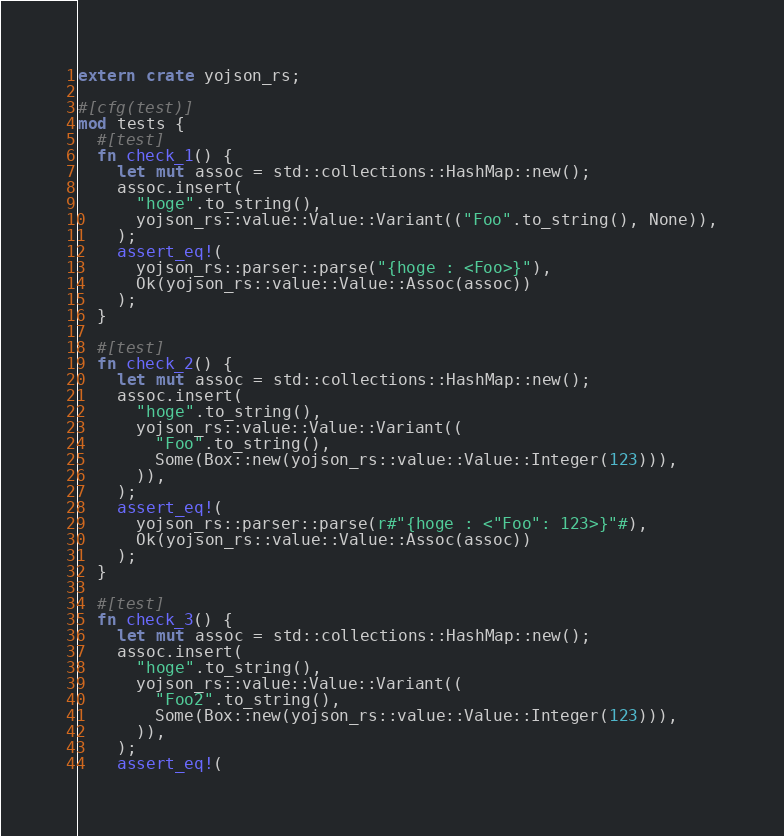<code> <loc_0><loc_0><loc_500><loc_500><_Rust_>extern crate yojson_rs;

#[cfg(test)]
mod tests {
  #[test]
  fn check_1() {
    let mut assoc = std::collections::HashMap::new();
    assoc.insert(
      "hoge".to_string(),
      yojson_rs::value::Value::Variant(("Foo".to_string(), None)),
    );
    assert_eq!(
      yojson_rs::parser::parse("{hoge : <Foo>}"),
      Ok(yojson_rs::value::Value::Assoc(assoc))
    );
  }

  #[test]
  fn check_2() {
    let mut assoc = std::collections::HashMap::new();
    assoc.insert(
      "hoge".to_string(),
      yojson_rs::value::Value::Variant((
        "Foo".to_string(),
        Some(Box::new(yojson_rs::value::Value::Integer(123))),
      )),
    );
    assert_eq!(
      yojson_rs::parser::parse(r#"{hoge : <"Foo": 123>}"#),
      Ok(yojson_rs::value::Value::Assoc(assoc))
    );
  }

  #[test]
  fn check_3() {
    let mut assoc = std::collections::HashMap::new();
    assoc.insert(
      "hoge".to_string(),
      yojson_rs::value::Value::Variant((
        "Foo2".to_string(),
        Some(Box::new(yojson_rs::value::Value::Integer(123))),
      )),
    );
    assert_eq!(</code> 